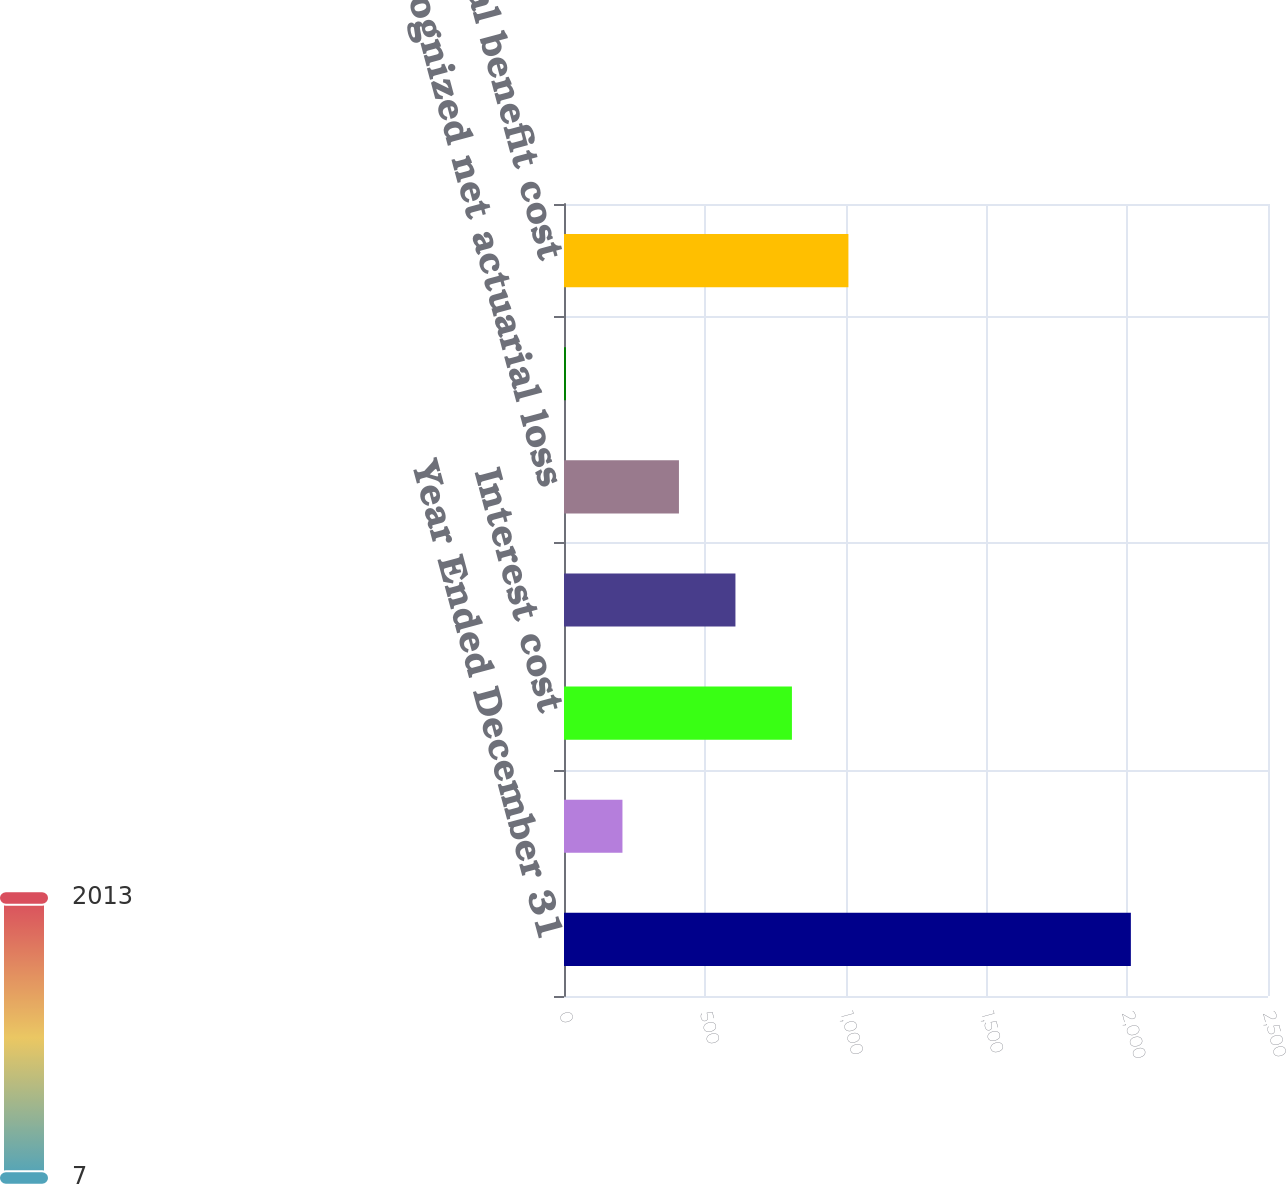<chart> <loc_0><loc_0><loc_500><loc_500><bar_chart><fcel>Year Ended December 31<fcel>Service cost<fcel>Interest cost<fcel>Expected return on plan assets<fcel>Recognized net actuarial loss<fcel>Amortization of prior service<fcel>Annual benefit cost<nl><fcel>2013<fcel>207.6<fcel>809.4<fcel>608.8<fcel>408.2<fcel>7<fcel>1010<nl></chart> 